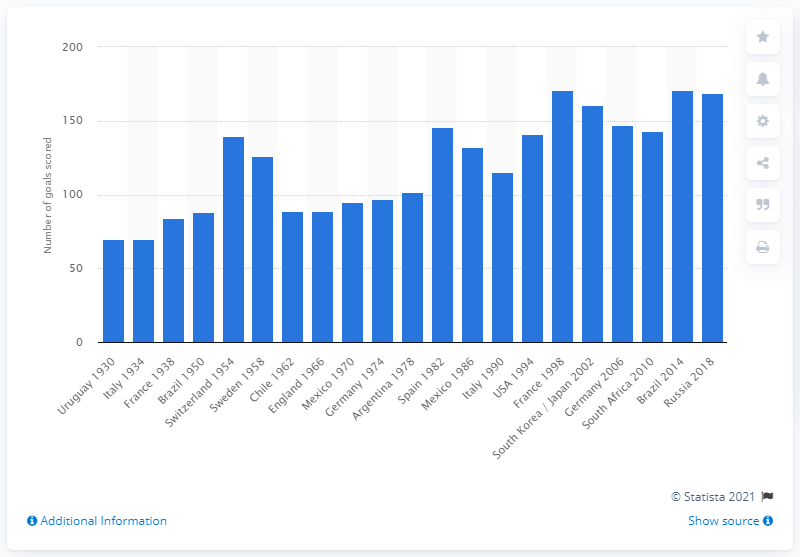Indicate a few pertinent items in this graphic. The 2014 FIFA World Cup saw the scoring of 171 goals. The previous record for goals scored in the 2014 FIFA World Cup was set by France in 1998. 